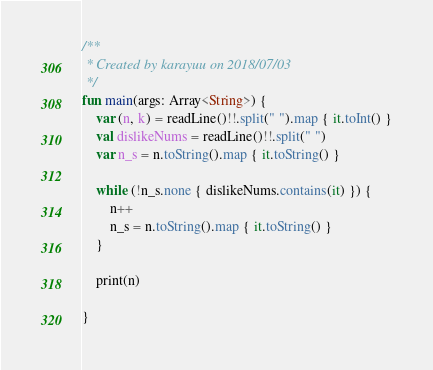Convert code to text. <code><loc_0><loc_0><loc_500><loc_500><_Kotlin_>/**
 * Created by karayuu on 2018/07/03
 */
fun main(args: Array<String>) {
    var (n, k) = readLine()!!.split(" ").map { it.toInt() }
    val dislikeNums = readLine()!!.split(" ")
    var n_s = n.toString().map { it.toString() }

    while (!n_s.none { dislikeNums.contains(it) }) {
        n++
        n_s = n.toString().map { it.toString() }
    }

    print(n)

}
</code> 